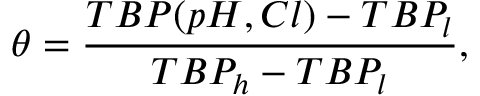Convert formula to latex. <formula><loc_0><loc_0><loc_500><loc_500>\theta = \frac { T B P ( p H , C l ) - T B P _ { l } } { T B P _ { h } - T B P _ { l } } ,</formula> 